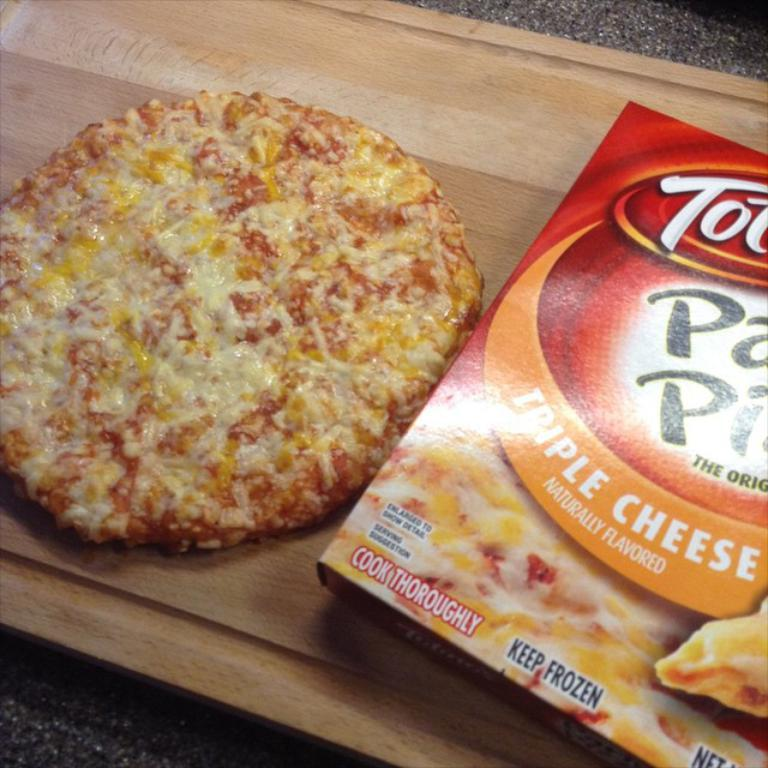What object is present in the image that might contain something? There is a box in the image that might contain something. What type of food can be seen in the image? There is a pizza in the image. On what surface are the box and pizza placed? The box and pizza are placed on a wooden surface. What type of stocking is being used to play volleyball in the image? There is no volleyball or stocking present in the image; it only features a box and a pizza on a wooden surface. 